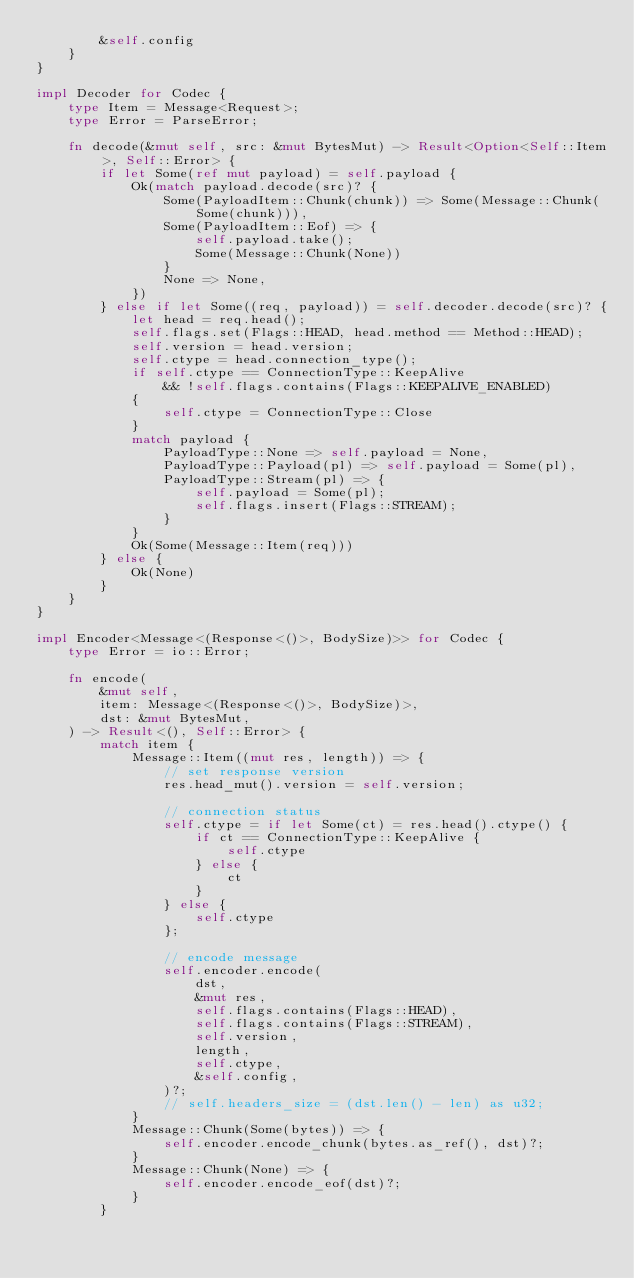<code> <loc_0><loc_0><loc_500><loc_500><_Rust_>        &self.config
    }
}

impl Decoder for Codec {
    type Item = Message<Request>;
    type Error = ParseError;

    fn decode(&mut self, src: &mut BytesMut) -> Result<Option<Self::Item>, Self::Error> {
        if let Some(ref mut payload) = self.payload {
            Ok(match payload.decode(src)? {
                Some(PayloadItem::Chunk(chunk)) => Some(Message::Chunk(Some(chunk))),
                Some(PayloadItem::Eof) => {
                    self.payload.take();
                    Some(Message::Chunk(None))
                }
                None => None,
            })
        } else if let Some((req, payload)) = self.decoder.decode(src)? {
            let head = req.head();
            self.flags.set(Flags::HEAD, head.method == Method::HEAD);
            self.version = head.version;
            self.ctype = head.connection_type();
            if self.ctype == ConnectionType::KeepAlive
                && !self.flags.contains(Flags::KEEPALIVE_ENABLED)
            {
                self.ctype = ConnectionType::Close
            }
            match payload {
                PayloadType::None => self.payload = None,
                PayloadType::Payload(pl) => self.payload = Some(pl),
                PayloadType::Stream(pl) => {
                    self.payload = Some(pl);
                    self.flags.insert(Flags::STREAM);
                }
            }
            Ok(Some(Message::Item(req)))
        } else {
            Ok(None)
        }
    }
}

impl Encoder<Message<(Response<()>, BodySize)>> for Codec {
    type Error = io::Error;

    fn encode(
        &mut self,
        item: Message<(Response<()>, BodySize)>,
        dst: &mut BytesMut,
    ) -> Result<(), Self::Error> {
        match item {
            Message::Item((mut res, length)) => {
                // set response version
                res.head_mut().version = self.version;

                // connection status
                self.ctype = if let Some(ct) = res.head().ctype() {
                    if ct == ConnectionType::KeepAlive {
                        self.ctype
                    } else {
                        ct
                    }
                } else {
                    self.ctype
                };

                // encode message
                self.encoder.encode(
                    dst,
                    &mut res,
                    self.flags.contains(Flags::HEAD),
                    self.flags.contains(Flags::STREAM),
                    self.version,
                    length,
                    self.ctype,
                    &self.config,
                )?;
                // self.headers_size = (dst.len() - len) as u32;
            }
            Message::Chunk(Some(bytes)) => {
                self.encoder.encode_chunk(bytes.as_ref(), dst)?;
            }
            Message::Chunk(None) => {
                self.encoder.encode_eof(dst)?;
            }
        }</code> 